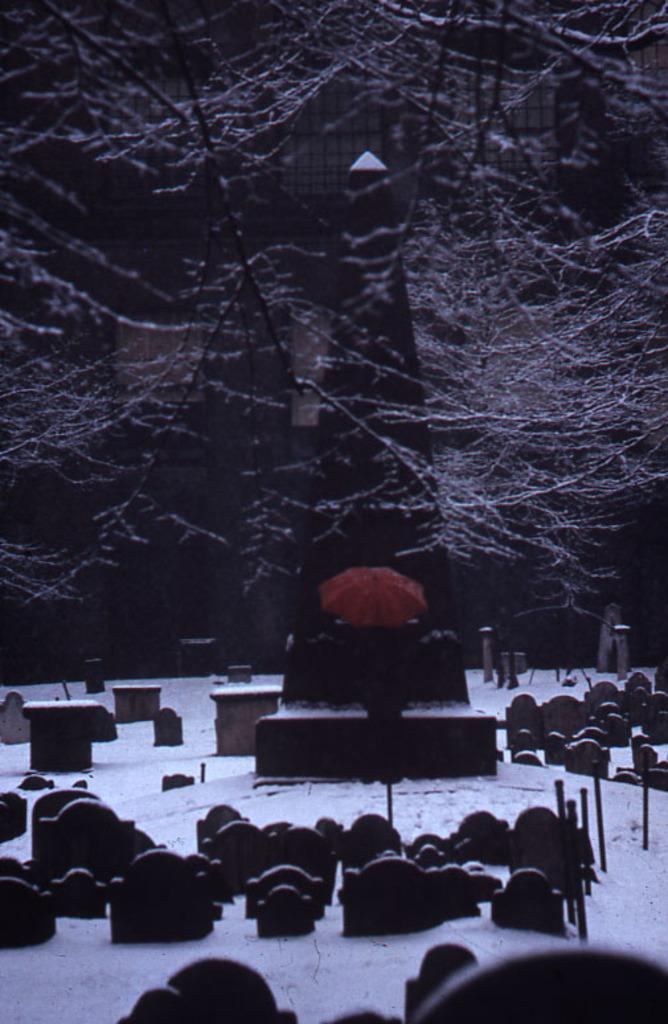What type of natural element can be seen in the image? There is a tree in the image. What is covering the ground in the image? There is snow at the bottom of the image. What type of man-made structure is visible in the image? There is a building in the front of the image. What objects can be seen on the right side of the image? There are poles and blocks on the right side of the image. Can you see a guitar being played in the image? There is no guitar or anyone playing a guitar in the image. How many shoes are visible in the image? There are no shoes visible in the image. 